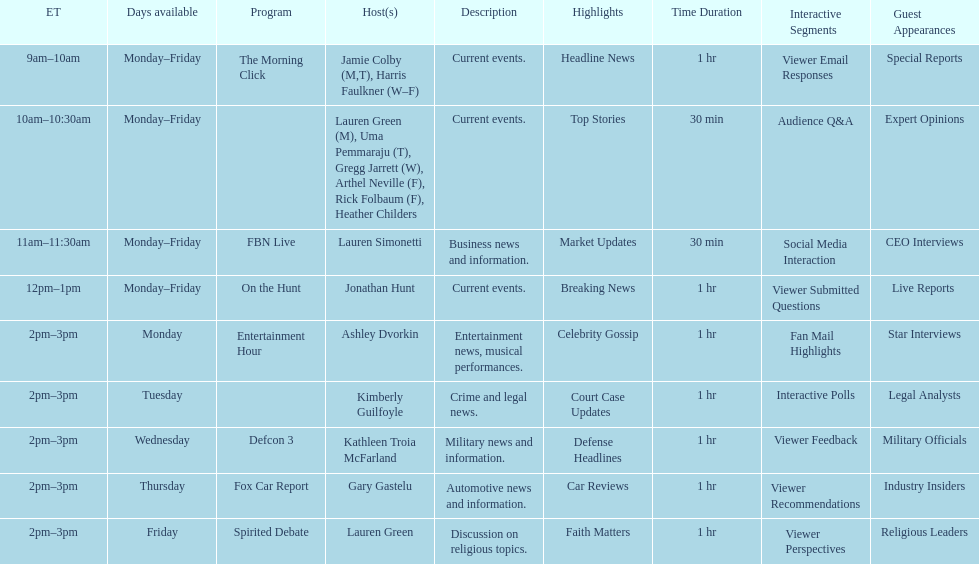On monday mornings, what is the premiere show to be broadcasted? The Morning Click. 